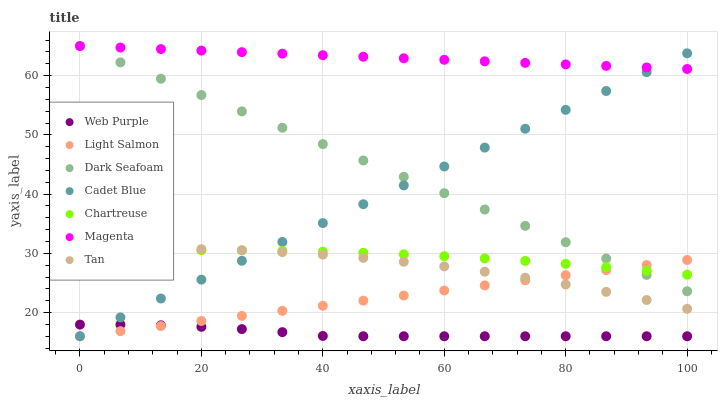Does Web Purple have the minimum area under the curve?
Answer yes or no. Yes. Does Magenta have the maximum area under the curve?
Answer yes or no. Yes. Does Cadet Blue have the minimum area under the curve?
Answer yes or no. No. Does Cadet Blue have the maximum area under the curve?
Answer yes or no. No. Is Light Salmon the smoothest?
Answer yes or no. Yes. Is Tan the roughest?
Answer yes or no. Yes. Is Cadet Blue the smoothest?
Answer yes or no. No. Is Cadet Blue the roughest?
Answer yes or no. No. Does Light Salmon have the lowest value?
Answer yes or no. Yes. Does Dark Seafoam have the lowest value?
Answer yes or no. No. Does Magenta have the highest value?
Answer yes or no. Yes. Does Cadet Blue have the highest value?
Answer yes or no. No. Is Light Salmon less than Magenta?
Answer yes or no. Yes. Is Tan greater than Web Purple?
Answer yes or no. Yes. Does Chartreuse intersect Tan?
Answer yes or no. Yes. Is Chartreuse less than Tan?
Answer yes or no. No. Is Chartreuse greater than Tan?
Answer yes or no. No. Does Light Salmon intersect Magenta?
Answer yes or no. No. 